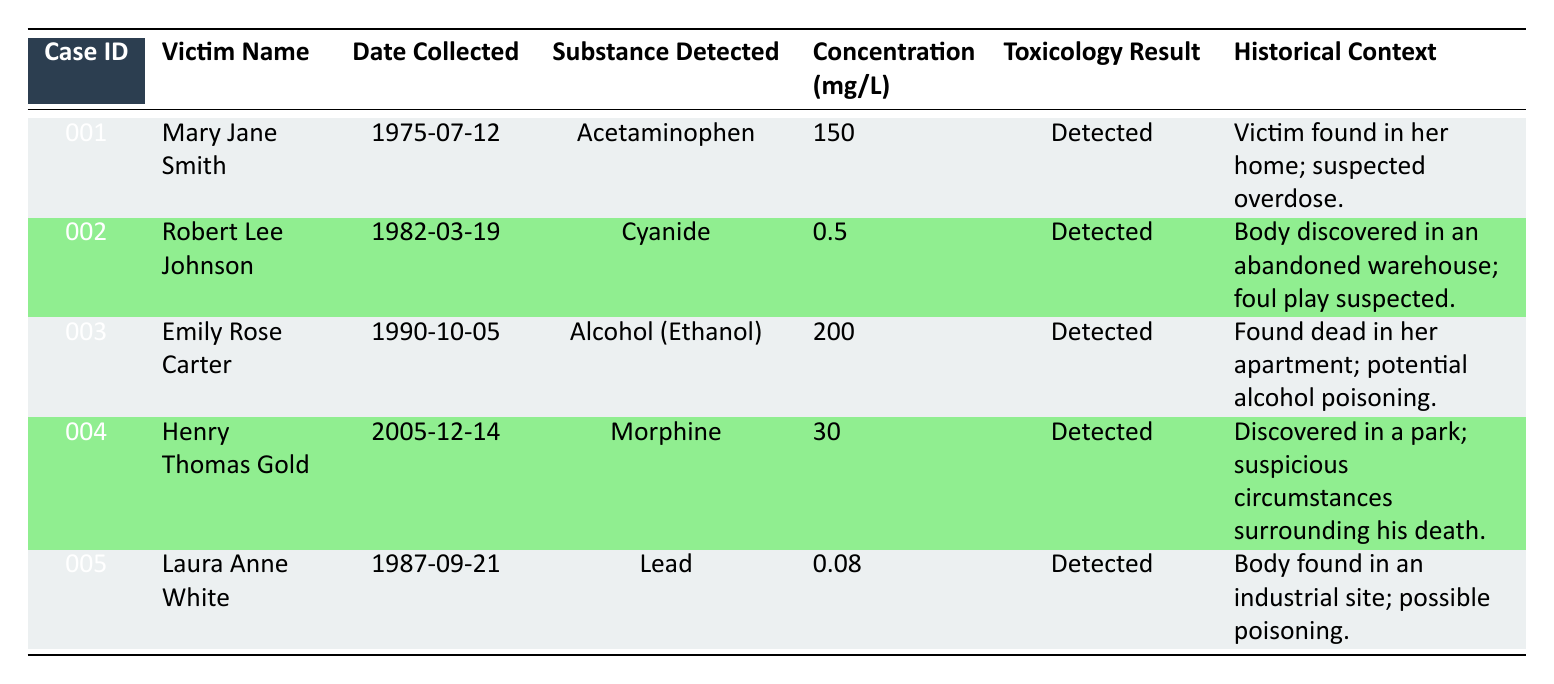What substance was detected in the case of Laura Anne White? The table states that the substance detected in Laura Anne White's case is Lead.
Answer: Lead How many cases involved substances detected in the 1980s? The cases of Robert Lee Johnson (1982) and Laura Anne White (1987) both occurred in the 1980s. Therefore, there are 2 cases.
Answer: 2 What is the concentration of Cyanide found in Robert Lee Johnson's toxicology report? According to the table, the concentration of Cyanide in Robert Lee Johnson's report is 0.5 mg per L.
Answer: 0.5 mg per L Which victim had the highest concentration of a substance detected? By comparing the concentration values in the table, Emily Rose Carter had the highest concentration, with Alcohol (Ethanol) at 200 mg per L.
Answer: Emily Rose Carter Is there any case where a substance was detected at a concentration lower than 1 mg per L? Yes, the case of Robert Lee Johnson showed a concentration of Cyanide at 0.5 mg per L, which is lower than 1 mg per L.
Answer: Yes What substances were detected in the cases from the 1970s and 1980s? In the 1970s, Acetaminophen was detected in Mary Jane Smith's case. In the 1980s, Cyanide was detected in Robert Lee Johnson's case and Lead was detected in Laura Anne White’s case.
Answer: Acetaminophen, Cyanide, Lead What is the average concentration of detected substances across all five cases? First, sum the concentrations: 150 (Acetaminophen) + 0.5 (Cyanide) + 200 (Ethanol) + 30 (Morphine) + 0.08 (Lead) = 380.58. There are 5 cases, so the average is 380.58/5 = 76.116.
Answer: 76.116 mg per L Which victim's death was associated with suspicious circumstances? The cases for Henry Thomas Gold and Laura Anne White indicate suspicious circumstances surrounding their deaths in the historical context described.
Answer: Henry Thomas Gold, Laura Anne White Are there any cases where the toxicology result states "Not Detected"? All listed cases in the table state the toxicology result as "Detected." Therefore, there are no cases with "Not Detected."
Answer: No 